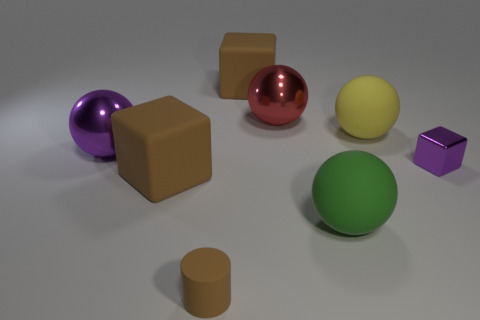Add 2 tiny rubber objects. How many objects exist? 10 Subtract all cylinders. How many objects are left? 7 Add 2 large purple spheres. How many large purple spheres exist? 3 Subtract 2 brown blocks. How many objects are left? 6 Subtract all blue metal blocks. Subtract all tiny purple metallic things. How many objects are left? 7 Add 6 matte cylinders. How many matte cylinders are left? 7 